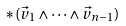Convert formula to latex. <formula><loc_0><loc_0><loc_500><loc_500>* ( \vec { v } _ { 1 } \wedge \dots \wedge \vec { v } _ { n - 1 } )</formula> 